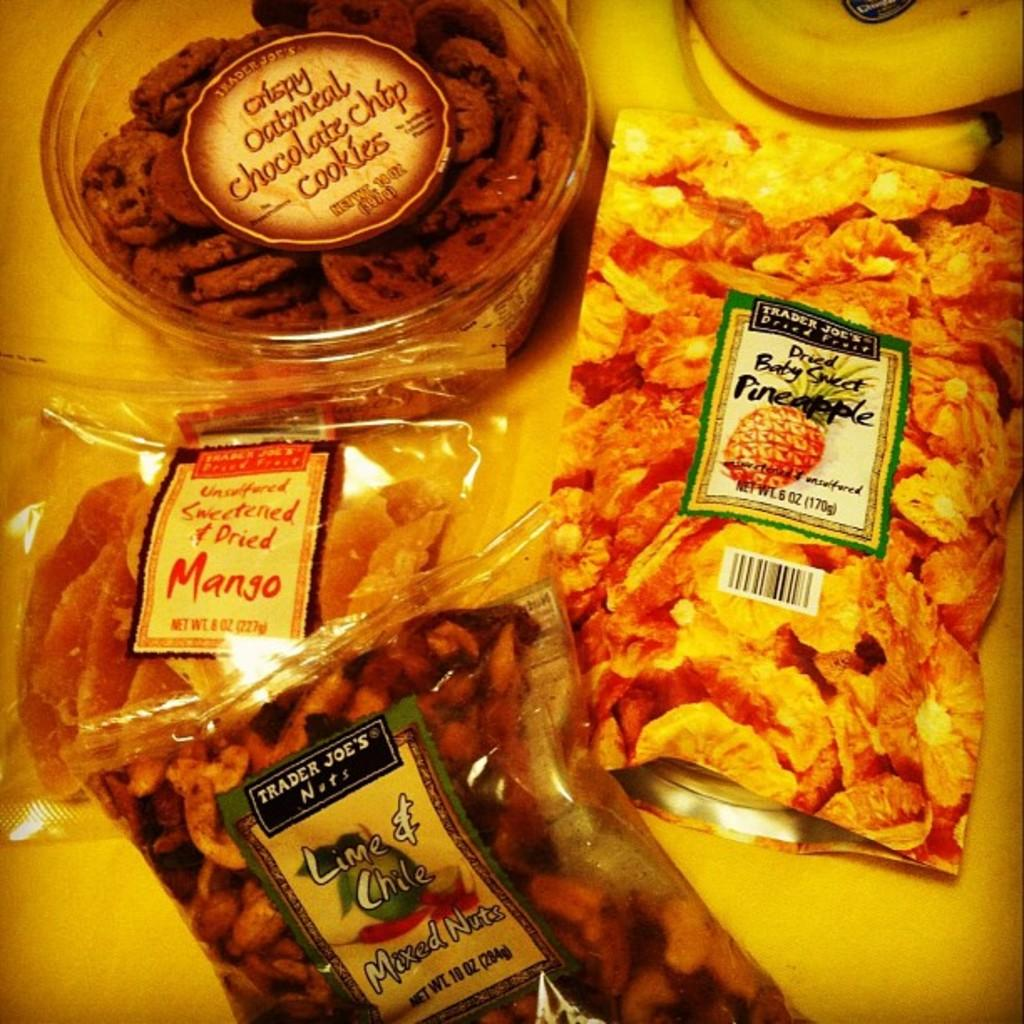What type of items can be seen in the image? There are food items in the image. How are the food items packaged or stored? The food items are in covers and boxes. Are there any identifying features on the covers and boxes? Yes, there are labels on the covers and boxes. Can you describe the setting where the food items are located? The image might depict a table at the bottom. What type of pickle is being used in the war depicted in the image? There is no war or pickle present in the image; it features food items in covers and boxes with labels. 